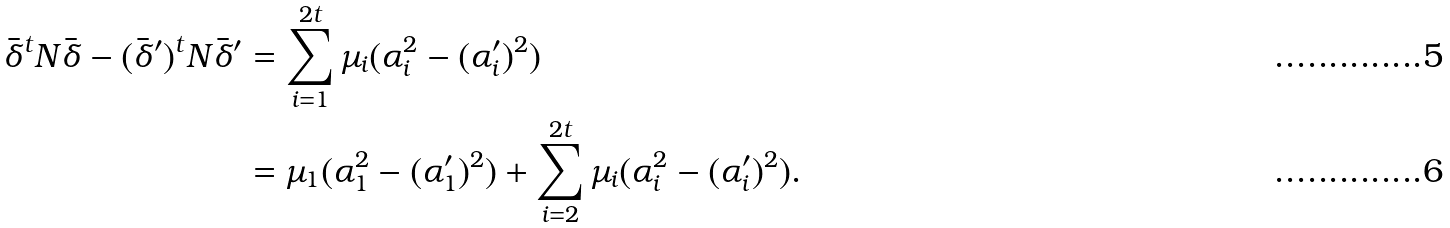<formula> <loc_0><loc_0><loc_500><loc_500>\bar { \delta } ^ { t } N \bar { \delta } - ( \bar { \delta } ^ { \prime } ) ^ { t } N \bar { \delta } ^ { \prime } & = \sum _ { i = 1 } ^ { 2 t } \mu _ { i } ( \alpha _ { i } ^ { 2 } - ( \alpha _ { i } ^ { \prime } ) ^ { 2 } ) \\ & = \mu _ { 1 } ( \alpha _ { 1 } ^ { 2 } - ( \alpha _ { 1 } ^ { \prime } ) ^ { 2 } ) + \sum _ { i = 2 } ^ { 2 t } \mu _ { i } ( \alpha _ { i } ^ { 2 } - ( \alpha _ { i } ^ { \prime } ) ^ { 2 } ) .</formula> 